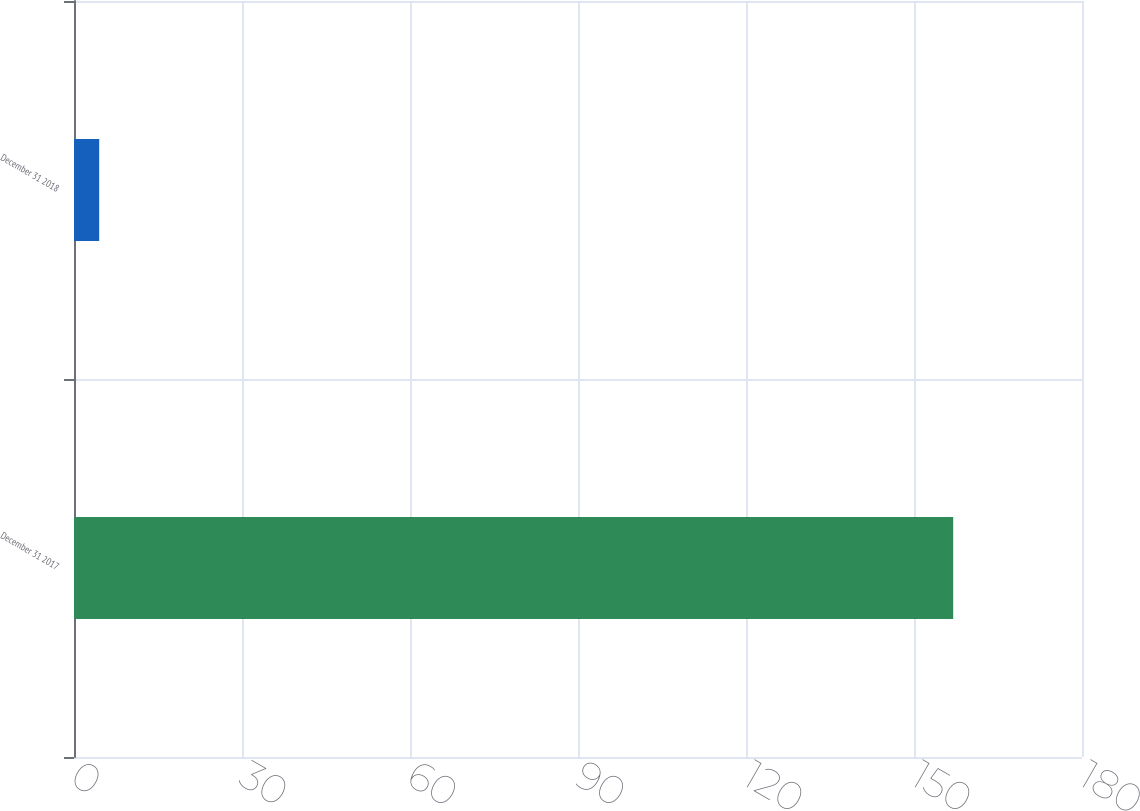<chart> <loc_0><loc_0><loc_500><loc_500><bar_chart><fcel>December 31 2017<fcel>December 31 2018<nl><fcel>157<fcel>4.5<nl></chart> 